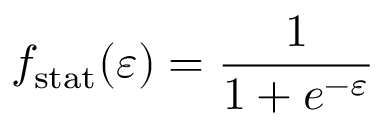Convert formula to latex. <formula><loc_0><loc_0><loc_500><loc_500>f _ { s t a t } ( \varepsilon ) = \frac { 1 } 1 + e ^ { - \varepsilon } }</formula> 